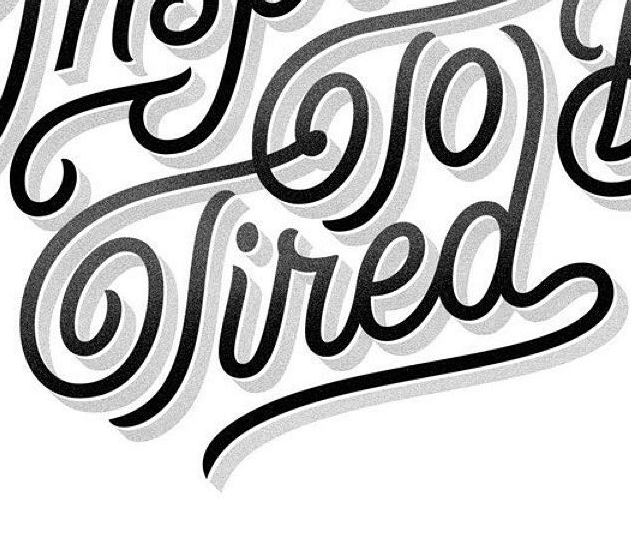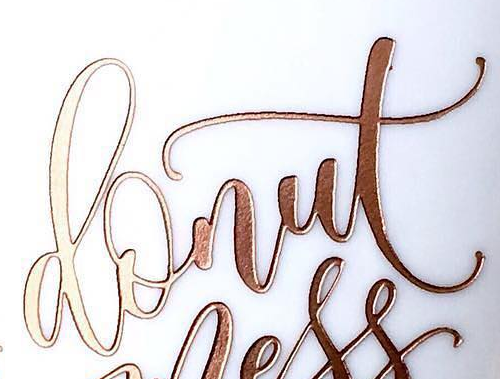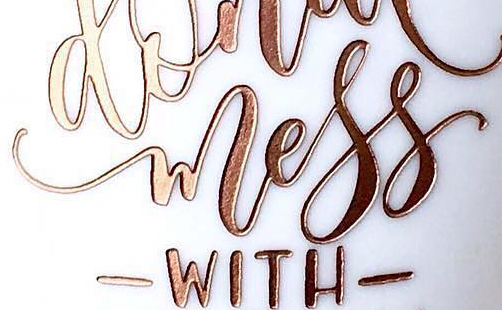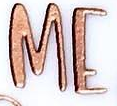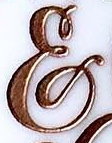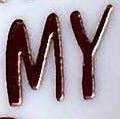What text is displayed in these images sequentially, separated by a semicolon? Tired; donut; wless; ME; &; MY 